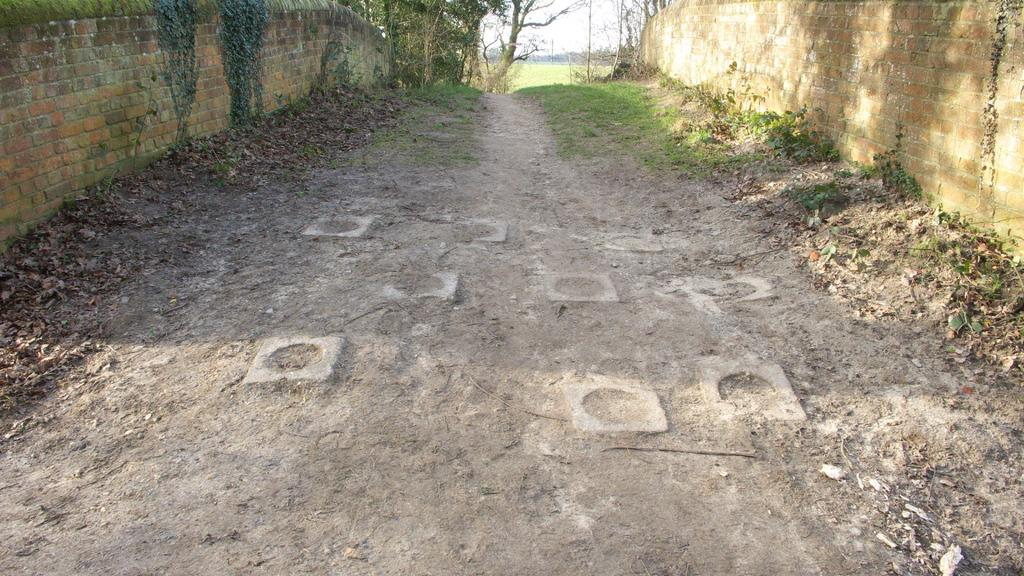What type of vegetation is present in the image? There is grass in the image. What else can be seen on the ground in the image? There are dried leaves on the ground. What type of structures are visible in the image? There are walls visible in the image. What can be seen in the background of the image? There are trees and the sky visible in the background of the image. How many rings are being shown on the lamp in the image? There is no lamp or rings present in the image. What type of show is being performed in the image? There is no show or performance taking place in the image. 